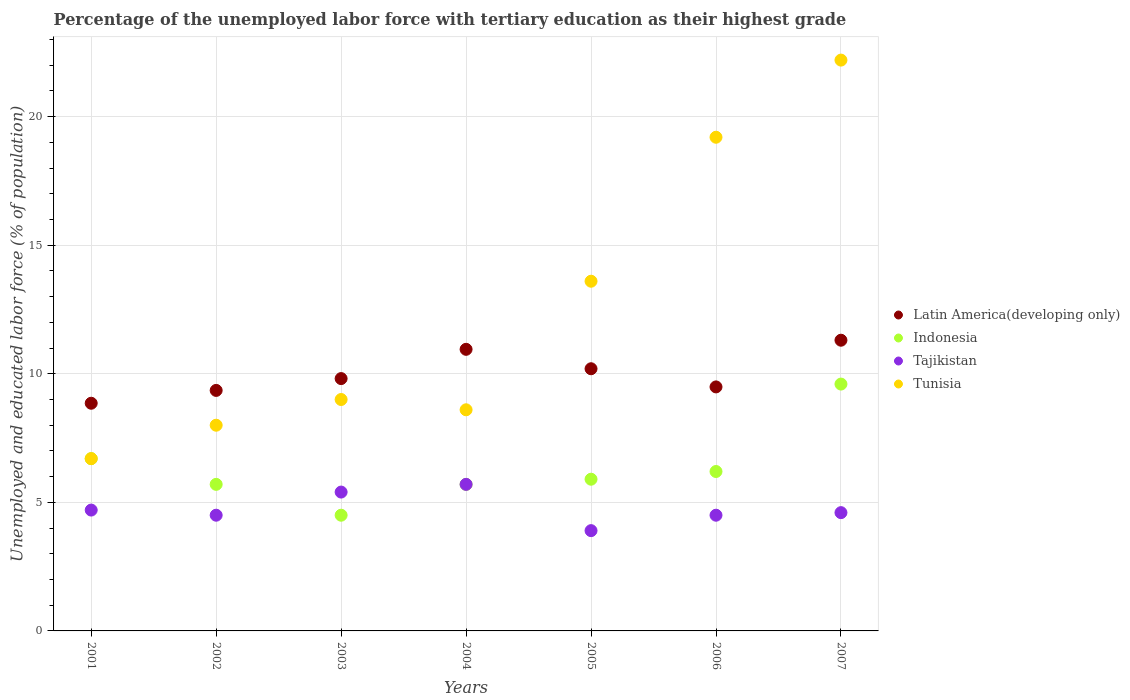Is the number of dotlines equal to the number of legend labels?
Ensure brevity in your answer.  Yes. What is the percentage of the unemployed labor force with tertiary education in Tajikistan in 2002?
Your response must be concise. 4.5. Across all years, what is the maximum percentage of the unemployed labor force with tertiary education in Latin America(developing only)?
Your response must be concise. 11.31. Across all years, what is the minimum percentage of the unemployed labor force with tertiary education in Latin America(developing only)?
Offer a terse response. 8.85. What is the total percentage of the unemployed labor force with tertiary education in Tunisia in the graph?
Your response must be concise. 87.3. What is the difference between the percentage of the unemployed labor force with tertiary education in Latin America(developing only) in 2005 and that in 2006?
Offer a terse response. 0.71. What is the difference between the percentage of the unemployed labor force with tertiary education in Latin America(developing only) in 2006 and the percentage of the unemployed labor force with tertiary education in Tunisia in 2005?
Give a very brief answer. -4.11. What is the average percentage of the unemployed labor force with tertiary education in Indonesia per year?
Keep it short and to the point. 6.33. In the year 2004, what is the difference between the percentage of the unemployed labor force with tertiary education in Tunisia and percentage of the unemployed labor force with tertiary education in Latin America(developing only)?
Your response must be concise. -2.35. In how many years, is the percentage of the unemployed labor force with tertiary education in Tunisia greater than 6 %?
Make the answer very short. 7. What is the ratio of the percentage of the unemployed labor force with tertiary education in Latin America(developing only) in 2004 to that in 2006?
Offer a terse response. 1.15. Is the percentage of the unemployed labor force with tertiary education in Tajikistan in 2003 less than that in 2007?
Provide a short and direct response. No. Is the difference between the percentage of the unemployed labor force with tertiary education in Tunisia in 2002 and 2004 greater than the difference between the percentage of the unemployed labor force with tertiary education in Latin America(developing only) in 2002 and 2004?
Provide a short and direct response. Yes. What is the difference between the highest and the lowest percentage of the unemployed labor force with tertiary education in Indonesia?
Keep it short and to the point. 5.1. Is it the case that in every year, the sum of the percentage of the unemployed labor force with tertiary education in Tunisia and percentage of the unemployed labor force with tertiary education in Indonesia  is greater than the sum of percentage of the unemployed labor force with tertiary education in Latin America(developing only) and percentage of the unemployed labor force with tertiary education in Tajikistan?
Keep it short and to the point. No. Is the percentage of the unemployed labor force with tertiary education in Tajikistan strictly greater than the percentage of the unemployed labor force with tertiary education in Latin America(developing only) over the years?
Provide a short and direct response. No. How many dotlines are there?
Make the answer very short. 4. What is the difference between two consecutive major ticks on the Y-axis?
Offer a terse response. 5. Does the graph contain grids?
Your answer should be very brief. Yes. How many legend labels are there?
Your response must be concise. 4. What is the title of the graph?
Offer a terse response. Percentage of the unemployed labor force with tertiary education as their highest grade. What is the label or title of the X-axis?
Your answer should be very brief. Years. What is the label or title of the Y-axis?
Keep it short and to the point. Unemployed and educated labor force (% of population). What is the Unemployed and educated labor force (% of population) in Latin America(developing only) in 2001?
Make the answer very short. 8.85. What is the Unemployed and educated labor force (% of population) in Indonesia in 2001?
Provide a succinct answer. 6.7. What is the Unemployed and educated labor force (% of population) in Tajikistan in 2001?
Ensure brevity in your answer.  4.7. What is the Unemployed and educated labor force (% of population) of Tunisia in 2001?
Keep it short and to the point. 6.7. What is the Unemployed and educated labor force (% of population) in Latin America(developing only) in 2002?
Provide a succinct answer. 9.35. What is the Unemployed and educated labor force (% of population) in Indonesia in 2002?
Keep it short and to the point. 5.7. What is the Unemployed and educated labor force (% of population) of Tunisia in 2002?
Ensure brevity in your answer.  8. What is the Unemployed and educated labor force (% of population) in Latin America(developing only) in 2003?
Offer a very short reply. 9.81. What is the Unemployed and educated labor force (% of population) of Indonesia in 2003?
Offer a terse response. 4.5. What is the Unemployed and educated labor force (% of population) of Tajikistan in 2003?
Provide a succinct answer. 5.4. What is the Unemployed and educated labor force (% of population) in Latin America(developing only) in 2004?
Offer a very short reply. 10.95. What is the Unemployed and educated labor force (% of population) in Indonesia in 2004?
Provide a succinct answer. 5.7. What is the Unemployed and educated labor force (% of population) in Tajikistan in 2004?
Provide a short and direct response. 5.7. What is the Unemployed and educated labor force (% of population) of Tunisia in 2004?
Your answer should be compact. 8.6. What is the Unemployed and educated labor force (% of population) of Latin America(developing only) in 2005?
Provide a succinct answer. 10.2. What is the Unemployed and educated labor force (% of population) in Indonesia in 2005?
Make the answer very short. 5.9. What is the Unemployed and educated labor force (% of population) of Tajikistan in 2005?
Offer a very short reply. 3.9. What is the Unemployed and educated labor force (% of population) of Tunisia in 2005?
Offer a very short reply. 13.6. What is the Unemployed and educated labor force (% of population) of Latin America(developing only) in 2006?
Your answer should be very brief. 9.49. What is the Unemployed and educated labor force (% of population) of Indonesia in 2006?
Keep it short and to the point. 6.2. What is the Unemployed and educated labor force (% of population) in Tajikistan in 2006?
Your answer should be very brief. 4.5. What is the Unemployed and educated labor force (% of population) in Tunisia in 2006?
Offer a terse response. 19.2. What is the Unemployed and educated labor force (% of population) in Latin America(developing only) in 2007?
Provide a short and direct response. 11.31. What is the Unemployed and educated labor force (% of population) of Indonesia in 2007?
Offer a terse response. 9.6. What is the Unemployed and educated labor force (% of population) in Tajikistan in 2007?
Offer a very short reply. 4.6. What is the Unemployed and educated labor force (% of population) in Tunisia in 2007?
Your response must be concise. 22.2. Across all years, what is the maximum Unemployed and educated labor force (% of population) in Latin America(developing only)?
Keep it short and to the point. 11.31. Across all years, what is the maximum Unemployed and educated labor force (% of population) in Indonesia?
Your response must be concise. 9.6. Across all years, what is the maximum Unemployed and educated labor force (% of population) in Tajikistan?
Give a very brief answer. 5.7. Across all years, what is the maximum Unemployed and educated labor force (% of population) of Tunisia?
Make the answer very short. 22.2. Across all years, what is the minimum Unemployed and educated labor force (% of population) in Latin America(developing only)?
Ensure brevity in your answer.  8.85. Across all years, what is the minimum Unemployed and educated labor force (% of population) in Indonesia?
Offer a very short reply. 4.5. Across all years, what is the minimum Unemployed and educated labor force (% of population) of Tajikistan?
Your answer should be very brief. 3.9. Across all years, what is the minimum Unemployed and educated labor force (% of population) in Tunisia?
Provide a short and direct response. 6.7. What is the total Unemployed and educated labor force (% of population) of Latin America(developing only) in the graph?
Provide a succinct answer. 69.97. What is the total Unemployed and educated labor force (% of population) in Indonesia in the graph?
Your response must be concise. 44.3. What is the total Unemployed and educated labor force (% of population) in Tajikistan in the graph?
Your answer should be very brief. 33.3. What is the total Unemployed and educated labor force (% of population) in Tunisia in the graph?
Provide a succinct answer. 87.3. What is the difference between the Unemployed and educated labor force (% of population) of Latin America(developing only) in 2001 and that in 2002?
Give a very brief answer. -0.5. What is the difference between the Unemployed and educated labor force (% of population) of Tajikistan in 2001 and that in 2002?
Offer a terse response. 0.2. What is the difference between the Unemployed and educated labor force (% of population) of Tunisia in 2001 and that in 2002?
Offer a terse response. -1.3. What is the difference between the Unemployed and educated labor force (% of population) in Latin America(developing only) in 2001 and that in 2003?
Give a very brief answer. -0.96. What is the difference between the Unemployed and educated labor force (% of population) in Indonesia in 2001 and that in 2003?
Provide a short and direct response. 2.2. What is the difference between the Unemployed and educated labor force (% of population) in Tunisia in 2001 and that in 2003?
Keep it short and to the point. -2.3. What is the difference between the Unemployed and educated labor force (% of population) in Latin America(developing only) in 2001 and that in 2004?
Make the answer very short. -2.1. What is the difference between the Unemployed and educated labor force (% of population) of Indonesia in 2001 and that in 2004?
Offer a very short reply. 1. What is the difference between the Unemployed and educated labor force (% of population) of Latin America(developing only) in 2001 and that in 2005?
Provide a succinct answer. -1.34. What is the difference between the Unemployed and educated labor force (% of population) of Latin America(developing only) in 2001 and that in 2006?
Ensure brevity in your answer.  -0.64. What is the difference between the Unemployed and educated labor force (% of population) of Tunisia in 2001 and that in 2006?
Make the answer very short. -12.5. What is the difference between the Unemployed and educated labor force (% of population) of Latin America(developing only) in 2001 and that in 2007?
Offer a terse response. -2.45. What is the difference between the Unemployed and educated labor force (% of population) of Tunisia in 2001 and that in 2007?
Your answer should be compact. -15.5. What is the difference between the Unemployed and educated labor force (% of population) of Latin America(developing only) in 2002 and that in 2003?
Give a very brief answer. -0.46. What is the difference between the Unemployed and educated labor force (% of population) of Tajikistan in 2002 and that in 2003?
Your answer should be very brief. -0.9. What is the difference between the Unemployed and educated labor force (% of population) of Tunisia in 2002 and that in 2003?
Provide a short and direct response. -1. What is the difference between the Unemployed and educated labor force (% of population) of Latin America(developing only) in 2002 and that in 2004?
Offer a very short reply. -1.6. What is the difference between the Unemployed and educated labor force (% of population) of Indonesia in 2002 and that in 2004?
Ensure brevity in your answer.  0. What is the difference between the Unemployed and educated labor force (% of population) in Tunisia in 2002 and that in 2004?
Your response must be concise. -0.6. What is the difference between the Unemployed and educated labor force (% of population) in Latin America(developing only) in 2002 and that in 2005?
Your answer should be very brief. -0.84. What is the difference between the Unemployed and educated labor force (% of population) in Tunisia in 2002 and that in 2005?
Your response must be concise. -5.6. What is the difference between the Unemployed and educated labor force (% of population) of Latin America(developing only) in 2002 and that in 2006?
Offer a very short reply. -0.14. What is the difference between the Unemployed and educated labor force (% of population) of Latin America(developing only) in 2002 and that in 2007?
Your answer should be very brief. -1.95. What is the difference between the Unemployed and educated labor force (% of population) of Indonesia in 2002 and that in 2007?
Your answer should be very brief. -3.9. What is the difference between the Unemployed and educated labor force (% of population) in Tajikistan in 2002 and that in 2007?
Your response must be concise. -0.1. What is the difference between the Unemployed and educated labor force (% of population) of Tunisia in 2002 and that in 2007?
Give a very brief answer. -14.2. What is the difference between the Unemployed and educated labor force (% of population) in Latin America(developing only) in 2003 and that in 2004?
Your response must be concise. -1.14. What is the difference between the Unemployed and educated labor force (% of population) of Indonesia in 2003 and that in 2004?
Ensure brevity in your answer.  -1.2. What is the difference between the Unemployed and educated labor force (% of population) of Latin America(developing only) in 2003 and that in 2005?
Offer a terse response. -0.38. What is the difference between the Unemployed and educated labor force (% of population) in Tajikistan in 2003 and that in 2005?
Make the answer very short. 1.5. What is the difference between the Unemployed and educated labor force (% of population) of Latin America(developing only) in 2003 and that in 2006?
Offer a very short reply. 0.32. What is the difference between the Unemployed and educated labor force (% of population) of Indonesia in 2003 and that in 2006?
Your answer should be compact. -1.7. What is the difference between the Unemployed and educated labor force (% of population) in Tunisia in 2003 and that in 2006?
Make the answer very short. -10.2. What is the difference between the Unemployed and educated labor force (% of population) in Latin America(developing only) in 2003 and that in 2007?
Provide a short and direct response. -1.49. What is the difference between the Unemployed and educated labor force (% of population) of Indonesia in 2003 and that in 2007?
Keep it short and to the point. -5.1. What is the difference between the Unemployed and educated labor force (% of population) in Latin America(developing only) in 2004 and that in 2005?
Provide a succinct answer. 0.76. What is the difference between the Unemployed and educated labor force (% of population) of Tunisia in 2004 and that in 2005?
Ensure brevity in your answer.  -5. What is the difference between the Unemployed and educated labor force (% of population) in Latin America(developing only) in 2004 and that in 2006?
Provide a short and direct response. 1.46. What is the difference between the Unemployed and educated labor force (% of population) of Indonesia in 2004 and that in 2006?
Your answer should be very brief. -0.5. What is the difference between the Unemployed and educated labor force (% of population) of Tajikistan in 2004 and that in 2006?
Offer a very short reply. 1.2. What is the difference between the Unemployed and educated labor force (% of population) of Tunisia in 2004 and that in 2006?
Give a very brief answer. -10.6. What is the difference between the Unemployed and educated labor force (% of population) in Latin America(developing only) in 2004 and that in 2007?
Make the answer very short. -0.35. What is the difference between the Unemployed and educated labor force (% of population) of Tajikistan in 2004 and that in 2007?
Make the answer very short. 1.1. What is the difference between the Unemployed and educated labor force (% of population) of Tunisia in 2004 and that in 2007?
Your answer should be very brief. -13.6. What is the difference between the Unemployed and educated labor force (% of population) of Latin America(developing only) in 2005 and that in 2006?
Provide a short and direct response. 0.71. What is the difference between the Unemployed and educated labor force (% of population) in Indonesia in 2005 and that in 2006?
Ensure brevity in your answer.  -0.3. What is the difference between the Unemployed and educated labor force (% of population) of Latin America(developing only) in 2005 and that in 2007?
Offer a very short reply. -1.11. What is the difference between the Unemployed and educated labor force (% of population) in Tajikistan in 2005 and that in 2007?
Provide a succinct answer. -0.7. What is the difference between the Unemployed and educated labor force (% of population) in Latin America(developing only) in 2006 and that in 2007?
Provide a short and direct response. -1.82. What is the difference between the Unemployed and educated labor force (% of population) of Indonesia in 2006 and that in 2007?
Your answer should be very brief. -3.4. What is the difference between the Unemployed and educated labor force (% of population) in Latin America(developing only) in 2001 and the Unemployed and educated labor force (% of population) in Indonesia in 2002?
Your response must be concise. 3.15. What is the difference between the Unemployed and educated labor force (% of population) of Latin America(developing only) in 2001 and the Unemployed and educated labor force (% of population) of Tajikistan in 2002?
Your answer should be compact. 4.35. What is the difference between the Unemployed and educated labor force (% of population) of Latin America(developing only) in 2001 and the Unemployed and educated labor force (% of population) of Tunisia in 2002?
Offer a very short reply. 0.85. What is the difference between the Unemployed and educated labor force (% of population) of Latin America(developing only) in 2001 and the Unemployed and educated labor force (% of population) of Indonesia in 2003?
Ensure brevity in your answer.  4.35. What is the difference between the Unemployed and educated labor force (% of population) in Latin America(developing only) in 2001 and the Unemployed and educated labor force (% of population) in Tajikistan in 2003?
Offer a very short reply. 3.45. What is the difference between the Unemployed and educated labor force (% of population) of Latin America(developing only) in 2001 and the Unemployed and educated labor force (% of population) of Tunisia in 2003?
Offer a terse response. -0.15. What is the difference between the Unemployed and educated labor force (% of population) in Tajikistan in 2001 and the Unemployed and educated labor force (% of population) in Tunisia in 2003?
Provide a short and direct response. -4.3. What is the difference between the Unemployed and educated labor force (% of population) of Latin America(developing only) in 2001 and the Unemployed and educated labor force (% of population) of Indonesia in 2004?
Your response must be concise. 3.15. What is the difference between the Unemployed and educated labor force (% of population) in Latin America(developing only) in 2001 and the Unemployed and educated labor force (% of population) in Tajikistan in 2004?
Provide a short and direct response. 3.15. What is the difference between the Unemployed and educated labor force (% of population) in Latin America(developing only) in 2001 and the Unemployed and educated labor force (% of population) in Tunisia in 2004?
Provide a short and direct response. 0.25. What is the difference between the Unemployed and educated labor force (% of population) in Indonesia in 2001 and the Unemployed and educated labor force (% of population) in Tajikistan in 2004?
Make the answer very short. 1. What is the difference between the Unemployed and educated labor force (% of population) of Tajikistan in 2001 and the Unemployed and educated labor force (% of population) of Tunisia in 2004?
Your answer should be compact. -3.9. What is the difference between the Unemployed and educated labor force (% of population) of Latin America(developing only) in 2001 and the Unemployed and educated labor force (% of population) of Indonesia in 2005?
Your answer should be compact. 2.95. What is the difference between the Unemployed and educated labor force (% of population) in Latin America(developing only) in 2001 and the Unemployed and educated labor force (% of population) in Tajikistan in 2005?
Your answer should be compact. 4.95. What is the difference between the Unemployed and educated labor force (% of population) in Latin America(developing only) in 2001 and the Unemployed and educated labor force (% of population) in Tunisia in 2005?
Keep it short and to the point. -4.75. What is the difference between the Unemployed and educated labor force (% of population) in Indonesia in 2001 and the Unemployed and educated labor force (% of population) in Tajikistan in 2005?
Give a very brief answer. 2.8. What is the difference between the Unemployed and educated labor force (% of population) in Indonesia in 2001 and the Unemployed and educated labor force (% of population) in Tunisia in 2005?
Your response must be concise. -6.9. What is the difference between the Unemployed and educated labor force (% of population) in Tajikistan in 2001 and the Unemployed and educated labor force (% of population) in Tunisia in 2005?
Your answer should be very brief. -8.9. What is the difference between the Unemployed and educated labor force (% of population) of Latin America(developing only) in 2001 and the Unemployed and educated labor force (% of population) of Indonesia in 2006?
Ensure brevity in your answer.  2.65. What is the difference between the Unemployed and educated labor force (% of population) in Latin America(developing only) in 2001 and the Unemployed and educated labor force (% of population) in Tajikistan in 2006?
Your response must be concise. 4.35. What is the difference between the Unemployed and educated labor force (% of population) in Latin America(developing only) in 2001 and the Unemployed and educated labor force (% of population) in Tunisia in 2006?
Offer a terse response. -10.35. What is the difference between the Unemployed and educated labor force (% of population) in Indonesia in 2001 and the Unemployed and educated labor force (% of population) in Tajikistan in 2006?
Offer a terse response. 2.2. What is the difference between the Unemployed and educated labor force (% of population) of Tajikistan in 2001 and the Unemployed and educated labor force (% of population) of Tunisia in 2006?
Offer a very short reply. -14.5. What is the difference between the Unemployed and educated labor force (% of population) of Latin America(developing only) in 2001 and the Unemployed and educated labor force (% of population) of Indonesia in 2007?
Give a very brief answer. -0.75. What is the difference between the Unemployed and educated labor force (% of population) in Latin America(developing only) in 2001 and the Unemployed and educated labor force (% of population) in Tajikistan in 2007?
Offer a very short reply. 4.25. What is the difference between the Unemployed and educated labor force (% of population) in Latin America(developing only) in 2001 and the Unemployed and educated labor force (% of population) in Tunisia in 2007?
Your answer should be very brief. -13.35. What is the difference between the Unemployed and educated labor force (% of population) in Indonesia in 2001 and the Unemployed and educated labor force (% of population) in Tunisia in 2007?
Your answer should be very brief. -15.5. What is the difference between the Unemployed and educated labor force (% of population) of Tajikistan in 2001 and the Unemployed and educated labor force (% of population) of Tunisia in 2007?
Give a very brief answer. -17.5. What is the difference between the Unemployed and educated labor force (% of population) in Latin America(developing only) in 2002 and the Unemployed and educated labor force (% of population) in Indonesia in 2003?
Make the answer very short. 4.85. What is the difference between the Unemployed and educated labor force (% of population) in Latin America(developing only) in 2002 and the Unemployed and educated labor force (% of population) in Tajikistan in 2003?
Offer a very short reply. 3.95. What is the difference between the Unemployed and educated labor force (% of population) in Latin America(developing only) in 2002 and the Unemployed and educated labor force (% of population) in Tunisia in 2003?
Your answer should be very brief. 0.35. What is the difference between the Unemployed and educated labor force (% of population) of Indonesia in 2002 and the Unemployed and educated labor force (% of population) of Tajikistan in 2003?
Your response must be concise. 0.3. What is the difference between the Unemployed and educated labor force (% of population) of Latin America(developing only) in 2002 and the Unemployed and educated labor force (% of population) of Indonesia in 2004?
Provide a succinct answer. 3.65. What is the difference between the Unemployed and educated labor force (% of population) in Latin America(developing only) in 2002 and the Unemployed and educated labor force (% of population) in Tajikistan in 2004?
Ensure brevity in your answer.  3.65. What is the difference between the Unemployed and educated labor force (% of population) in Latin America(developing only) in 2002 and the Unemployed and educated labor force (% of population) in Tunisia in 2004?
Your answer should be very brief. 0.75. What is the difference between the Unemployed and educated labor force (% of population) of Indonesia in 2002 and the Unemployed and educated labor force (% of population) of Tunisia in 2004?
Your answer should be compact. -2.9. What is the difference between the Unemployed and educated labor force (% of population) in Tajikistan in 2002 and the Unemployed and educated labor force (% of population) in Tunisia in 2004?
Provide a short and direct response. -4.1. What is the difference between the Unemployed and educated labor force (% of population) of Latin America(developing only) in 2002 and the Unemployed and educated labor force (% of population) of Indonesia in 2005?
Your response must be concise. 3.45. What is the difference between the Unemployed and educated labor force (% of population) in Latin America(developing only) in 2002 and the Unemployed and educated labor force (% of population) in Tajikistan in 2005?
Ensure brevity in your answer.  5.45. What is the difference between the Unemployed and educated labor force (% of population) in Latin America(developing only) in 2002 and the Unemployed and educated labor force (% of population) in Tunisia in 2005?
Provide a succinct answer. -4.25. What is the difference between the Unemployed and educated labor force (% of population) of Tajikistan in 2002 and the Unemployed and educated labor force (% of population) of Tunisia in 2005?
Offer a terse response. -9.1. What is the difference between the Unemployed and educated labor force (% of population) in Latin America(developing only) in 2002 and the Unemployed and educated labor force (% of population) in Indonesia in 2006?
Provide a short and direct response. 3.15. What is the difference between the Unemployed and educated labor force (% of population) in Latin America(developing only) in 2002 and the Unemployed and educated labor force (% of population) in Tajikistan in 2006?
Offer a very short reply. 4.85. What is the difference between the Unemployed and educated labor force (% of population) in Latin America(developing only) in 2002 and the Unemployed and educated labor force (% of population) in Tunisia in 2006?
Offer a very short reply. -9.85. What is the difference between the Unemployed and educated labor force (% of population) of Indonesia in 2002 and the Unemployed and educated labor force (% of population) of Tajikistan in 2006?
Offer a terse response. 1.2. What is the difference between the Unemployed and educated labor force (% of population) of Tajikistan in 2002 and the Unemployed and educated labor force (% of population) of Tunisia in 2006?
Offer a terse response. -14.7. What is the difference between the Unemployed and educated labor force (% of population) in Latin America(developing only) in 2002 and the Unemployed and educated labor force (% of population) in Indonesia in 2007?
Keep it short and to the point. -0.25. What is the difference between the Unemployed and educated labor force (% of population) of Latin America(developing only) in 2002 and the Unemployed and educated labor force (% of population) of Tajikistan in 2007?
Your answer should be very brief. 4.75. What is the difference between the Unemployed and educated labor force (% of population) of Latin America(developing only) in 2002 and the Unemployed and educated labor force (% of population) of Tunisia in 2007?
Make the answer very short. -12.85. What is the difference between the Unemployed and educated labor force (% of population) in Indonesia in 2002 and the Unemployed and educated labor force (% of population) in Tajikistan in 2007?
Your answer should be very brief. 1.1. What is the difference between the Unemployed and educated labor force (% of population) in Indonesia in 2002 and the Unemployed and educated labor force (% of population) in Tunisia in 2007?
Keep it short and to the point. -16.5. What is the difference between the Unemployed and educated labor force (% of population) of Tajikistan in 2002 and the Unemployed and educated labor force (% of population) of Tunisia in 2007?
Your answer should be compact. -17.7. What is the difference between the Unemployed and educated labor force (% of population) in Latin America(developing only) in 2003 and the Unemployed and educated labor force (% of population) in Indonesia in 2004?
Ensure brevity in your answer.  4.11. What is the difference between the Unemployed and educated labor force (% of population) in Latin America(developing only) in 2003 and the Unemployed and educated labor force (% of population) in Tajikistan in 2004?
Keep it short and to the point. 4.11. What is the difference between the Unemployed and educated labor force (% of population) in Latin America(developing only) in 2003 and the Unemployed and educated labor force (% of population) in Tunisia in 2004?
Your answer should be compact. 1.21. What is the difference between the Unemployed and educated labor force (% of population) in Tajikistan in 2003 and the Unemployed and educated labor force (% of population) in Tunisia in 2004?
Your response must be concise. -3.2. What is the difference between the Unemployed and educated labor force (% of population) of Latin America(developing only) in 2003 and the Unemployed and educated labor force (% of population) of Indonesia in 2005?
Provide a short and direct response. 3.91. What is the difference between the Unemployed and educated labor force (% of population) in Latin America(developing only) in 2003 and the Unemployed and educated labor force (% of population) in Tajikistan in 2005?
Offer a terse response. 5.91. What is the difference between the Unemployed and educated labor force (% of population) of Latin America(developing only) in 2003 and the Unemployed and educated labor force (% of population) of Tunisia in 2005?
Offer a very short reply. -3.79. What is the difference between the Unemployed and educated labor force (% of population) in Indonesia in 2003 and the Unemployed and educated labor force (% of population) in Tajikistan in 2005?
Provide a short and direct response. 0.6. What is the difference between the Unemployed and educated labor force (% of population) in Latin America(developing only) in 2003 and the Unemployed and educated labor force (% of population) in Indonesia in 2006?
Your response must be concise. 3.61. What is the difference between the Unemployed and educated labor force (% of population) of Latin America(developing only) in 2003 and the Unemployed and educated labor force (% of population) of Tajikistan in 2006?
Your answer should be very brief. 5.31. What is the difference between the Unemployed and educated labor force (% of population) in Latin America(developing only) in 2003 and the Unemployed and educated labor force (% of population) in Tunisia in 2006?
Ensure brevity in your answer.  -9.39. What is the difference between the Unemployed and educated labor force (% of population) of Indonesia in 2003 and the Unemployed and educated labor force (% of population) of Tunisia in 2006?
Make the answer very short. -14.7. What is the difference between the Unemployed and educated labor force (% of population) of Tajikistan in 2003 and the Unemployed and educated labor force (% of population) of Tunisia in 2006?
Ensure brevity in your answer.  -13.8. What is the difference between the Unemployed and educated labor force (% of population) in Latin America(developing only) in 2003 and the Unemployed and educated labor force (% of population) in Indonesia in 2007?
Your response must be concise. 0.21. What is the difference between the Unemployed and educated labor force (% of population) in Latin America(developing only) in 2003 and the Unemployed and educated labor force (% of population) in Tajikistan in 2007?
Make the answer very short. 5.21. What is the difference between the Unemployed and educated labor force (% of population) of Latin America(developing only) in 2003 and the Unemployed and educated labor force (% of population) of Tunisia in 2007?
Give a very brief answer. -12.39. What is the difference between the Unemployed and educated labor force (% of population) of Indonesia in 2003 and the Unemployed and educated labor force (% of population) of Tunisia in 2007?
Your answer should be compact. -17.7. What is the difference between the Unemployed and educated labor force (% of population) of Tajikistan in 2003 and the Unemployed and educated labor force (% of population) of Tunisia in 2007?
Keep it short and to the point. -16.8. What is the difference between the Unemployed and educated labor force (% of population) of Latin America(developing only) in 2004 and the Unemployed and educated labor force (% of population) of Indonesia in 2005?
Ensure brevity in your answer.  5.05. What is the difference between the Unemployed and educated labor force (% of population) in Latin America(developing only) in 2004 and the Unemployed and educated labor force (% of population) in Tajikistan in 2005?
Offer a very short reply. 7.05. What is the difference between the Unemployed and educated labor force (% of population) in Latin America(developing only) in 2004 and the Unemployed and educated labor force (% of population) in Tunisia in 2005?
Your response must be concise. -2.65. What is the difference between the Unemployed and educated labor force (% of population) in Indonesia in 2004 and the Unemployed and educated labor force (% of population) in Tajikistan in 2005?
Provide a short and direct response. 1.8. What is the difference between the Unemployed and educated labor force (% of population) of Latin America(developing only) in 2004 and the Unemployed and educated labor force (% of population) of Indonesia in 2006?
Ensure brevity in your answer.  4.75. What is the difference between the Unemployed and educated labor force (% of population) of Latin America(developing only) in 2004 and the Unemployed and educated labor force (% of population) of Tajikistan in 2006?
Offer a terse response. 6.45. What is the difference between the Unemployed and educated labor force (% of population) of Latin America(developing only) in 2004 and the Unemployed and educated labor force (% of population) of Tunisia in 2006?
Keep it short and to the point. -8.25. What is the difference between the Unemployed and educated labor force (% of population) of Indonesia in 2004 and the Unemployed and educated labor force (% of population) of Tajikistan in 2006?
Give a very brief answer. 1.2. What is the difference between the Unemployed and educated labor force (% of population) in Indonesia in 2004 and the Unemployed and educated labor force (% of population) in Tunisia in 2006?
Keep it short and to the point. -13.5. What is the difference between the Unemployed and educated labor force (% of population) of Tajikistan in 2004 and the Unemployed and educated labor force (% of population) of Tunisia in 2006?
Keep it short and to the point. -13.5. What is the difference between the Unemployed and educated labor force (% of population) of Latin America(developing only) in 2004 and the Unemployed and educated labor force (% of population) of Indonesia in 2007?
Make the answer very short. 1.35. What is the difference between the Unemployed and educated labor force (% of population) of Latin America(developing only) in 2004 and the Unemployed and educated labor force (% of population) of Tajikistan in 2007?
Keep it short and to the point. 6.35. What is the difference between the Unemployed and educated labor force (% of population) in Latin America(developing only) in 2004 and the Unemployed and educated labor force (% of population) in Tunisia in 2007?
Make the answer very short. -11.25. What is the difference between the Unemployed and educated labor force (% of population) of Indonesia in 2004 and the Unemployed and educated labor force (% of population) of Tajikistan in 2007?
Make the answer very short. 1.1. What is the difference between the Unemployed and educated labor force (% of population) in Indonesia in 2004 and the Unemployed and educated labor force (% of population) in Tunisia in 2007?
Your answer should be very brief. -16.5. What is the difference between the Unemployed and educated labor force (% of population) in Tajikistan in 2004 and the Unemployed and educated labor force (% of population) in Tunisia in 2007?
Offer a terse response. -16.5. What is the difference between the Unemployed and educated labor force (% of population) of Latin America(developing only) in 2005 and the Unemployed and educated labor force (% of population) of Indonesia in 2006?
Keep it short and to the point. 4. What is the difference between the Unemployed and educated labor force (% of population) of Latin America(developing only) in 2005 and the Unemployed and educated labor force (% of population) of Tajikistan in 2006?
Your answer should be very brief. 5.7. What is the difference between the Unemployed and educated labor force (% of population) in Latin America(developing only) in 2005 and the Unemployed and educated labor force (% of population) in Tunisia in 2006?
Provide a short and direct response. -9. What is the difference between the Unemployed and educated labor force (% of population) in Indonesia in 2005 and the Unemployed and educated labor force (% of population) in Tajikistan in 2006?
Provide a succinct answer. 1.4. What is the difference between the Unemployed and educated labor force (% of population) of Tajikistan in 2005 and the Unemployed and educated labor force (% of population) of Tunisia in 2006?
Your answer should be compact. -15.3. What is the difference between the Unemployed and educated labor force (% of population) of Latin America(developing only) in 2005 and the Unemployed and educated labor force (% of population) of Indonesia in 2007?
Give a very brief answer. 0.6. What is the difference between the Unemployed and educated labor force (% of population) in Latin America(developing only) in 2005 and the Unemployed and educated labor force (% of population) in Tajikistan in 2007?
Ensure brevity in your answer.  5.6. What is the difference between the Unemployed and educated labor force (% of population) in Latin America(developing only) in 2005 and the Unemployed and educated labor force (% of population) in Tunisia in 2007?
Your answer should be compact. -12. What is the difference between the Unemployed and educated labor force (% of population) in Indonesia in 2005 and the Unemployed and educated labor force (% of population) in Tunisia in 2007?
Your answer should be compact. -16.3. What is the difference between the Unemployed and educated labor force (% of population) of Tajikistan in 2005 and the Unemployed and educated labor force (% of population) of Tunisia in 2007?
Your answer should be compact. -18.3. What is the difference between the Unemployed and educated labor force (% of population) in Latin America(developing only) in 2006 and the Unemployed and educated labor force (% of population) in Indonesia in 2007?
Keep it short and to the point. -0.11. What is the difference between the Unemployed and educated labor force (% of population) in Latin America(developing only) in 2006 and the Unemployed and educated labor force (% of population) in Tajikistan in 2007?
Provide a succinct answer. 4.89. What is the difference between the Unemployed and educated labor force (% of population) of Latin America(developing only) in 2006 and the Unemployed and educated labor force (% of population) of Tunisia in 2007?
Ensure brevity in your answer.  -12.71. What is the difference between the Unemployed and educated labor force (% of population) of Indonesia in 2006 and the Unemployed and educated labor force (% of population) of Tunisia in 2007?
Your answer should be very brief. -16. What is the difference between the Unemployed and educated labor force (% of population) in Tajikistan in 2006 and the Unemployed and educated labor force (% of population) in Tunisia in 2007?
Your response must be concise. -17.7. What is the average Unemployed and educated labor force (% of population) in Latin America(developing only) per year?
Offer a terse response. 10. What is the average Unemployed and educated labor force (% of population) in Indonesia per year?
Offer a terse response. 6.33. What is the average Unemployed and educated labor force (% of population) of Tajikistan per year?
Offer a terse response. 4.76. What is the average Unemployed and educated labor force (% of population) of Tunisia per year?
Provide a short and direct response. 12.47. In the year 2001, what is the difference between the Unemployed and educated labor force (% of population) in Latin America(developing only) and Unemployed and educated labor force (% of population) in Indonesia?
Your answer should be compact. 2.15. In the year 2001, what is the difference between the Unemployed and educated labor force (% of population) of Latin America(developing only) and Unemployed and educated labor force (% of population) of Tajikistan?
Provide a short and direct response. 4.15. In the year 2001, what is the difference between the Unemployed and educated labor force (% of population) of Latin America(developing only) and Unemployed and educated labor force (% of population) of Tunisia?
Make the answer very short. 2.15. In the year 2001, what is the difference between the Unemployed and educated labor force (% of population) of Indonesia and Unemployed and educated labor force (% of population) of Tajikistan?
Your response must be concise. 2. In the year 2002, what is the difference between the Unemployed and educated labor force (% of population) of Latin America(developing only) and Unemployed and educated labor force (% of population) of Indonesia?
Ensure brevity in your answer.  3.65. In the year 2002, what is the difference between the Unemployed and educated labor force (% of population) of Latin America(developing only) and Unemployed and educated labor force (% of population) of Tajikistan?
Ensure brevity in your answer.  4.85. In the year 2002, what is the difference between the Unemployed and educated labor force (% of population) in Latin America(developing only) and Unemployed and educated labor force (% of population) in Tunisia?
Your answer should be very brief. 1.35. In the year 2002, what is the difference between the Unemployed and educated labor force (% of population) in Indonesia and Unemployed and educated labor force (% of population) in Tajikistan?
Make the answer very short. 1.2. In the year 2003, what is the difference between the Unemployed and educated labor force (% of population) of Latin America(developing only) and Unemployed and educated labor force (% of population) of Indonesia?
Provide a succinct answer. 5.31. In the year 2003, what is the difference between the Unemployed and educated labor force (% of population) in Latin America(developing only) and Unemployed and educated labor force (% of population) in Tajikistan?
Keep it short and to the point. 4.41. In the year 2003, what is the difference between the Unemployed and educated labor force (% of population) in Latin America(developing only) and Unemployed and educated labor force (% of population) in Tunisia?
Your response must be concise. 0.81. In the year 2004, what is the difference between the Unemployed and educated labor force (% of population) in Latin America(developing only) and Unemployed and educated labor force (% of population) in Indonesia?
Your answer should be very brief. 5.25. In the year 2004, what is the difference between the Unemployed and educated labor force (% of population) of Latin America(developing only) and Unemployed and educated labor force (% of population) of Tajikistan?
Offer a very short reply. 5.25. In the year 2004, what is the difference between the Unemployed and educated labor force (% of population) of Latin America(developing only) and Unemployed and educated labor force (% of population) of Tunisia?
Provide a succinct answer. 2.35. In the year 2004, what is the difference between the Unemployed and educated labor force (% of population) of Indonesia and Unemployed and educated labor force (% of population) of Tajikistan?
Your answer should be very brief. 0. In the year 2004, what is the difference between the Unemployed and educated labor force (% of population) in Indonesia and Unemployed and educated labor force (% of population) in Tunisia?
Provide a short and direct response. -2.9. In the year 2005, what is the difference between the Unemployed and educated labor force (% of population) in Latin America(developing only) and Unemployed and educated labor force (% of population) in Indonesia?
Make the answer very short. 4.3. In the year 2005, what is the difference between the Unemployed and educated labor force (% of population) of Latin America(developing only) and Unemployed and educated labor force (% of population) of Tajikistan?
Make the answer very short. 6.3. In the year 2005, what is the difference between the Unemployed and educated labor force (% of population) of Latin America(developing only) and Unemployed and educated labor force (% of population) of Tunisia?
Provide a succinct answer. -3.4. In the year 2005, what is the difference between the Unemployed and educated labor force (% of population) in Tajikistan and Unemployed and educated labor force (% of population) in Tunisia?
Your answer should be compact. -9.7. In the year 2006, what is the difference between the Unemployed and educated labor force (% of population) in Latin America(developing only) and Unemployed and educated labor force (% of population) in Indonesia?
Give a very brief answer. 3.29. In the year 2006, what is the difference between the Unemployed and educated labor force (% of population) in Latin America(developing only) and Unemployed and educated labor force (% of population) in Tajikistan?
Offer a terse response. 4.99. In the year 2006, what is the difference between the Unemployed and educated labor force (% of population) of Latin America(developing only) and Unemployed and educated labor force (% of population) of Tunisia?
Provide a succinct answer. -9.71. In the year 2006, what is the difference between the Unemployed and educated labor force (% of population) of Indonesia and Unemployed and educated labor force (% of population) of Tunisia?
Make the answer very short. -13. In the year 2006, what is the difference between the Unemployed and educated labor force (% of population) of Tajikistan and Unemployed and educated labor force (% of population) of Tunisia?
Give a very brief answer. -14.7. In the year 2007, what is the difference between the Unemployed and educated labor force (% of population) in Latin America(developing only) and Unemployed and educated labor force (% of population) in Indonesia?
Provide a succinct answer. 1.71. In the year 2007, what is the difference between the Unemployed and educated labor force (% of population) in Latin America(developing only) and Unemployed and educated labor force (% of population) in Tajikistan?
Your answer should be very brief. 6.71. In the year 2007, what is the difference between the Unemployed and educated labor force (% of population) in Latin America(developing only) and Unemployed and educated labor force (% of population) in Tunisia?
Offer a terse response. -10.89. In the year 2007, what is the difference between the Unemployed and educated labor force (% of population) of Tajikistan and Unemployed and educated labor force (% of population) of Tunisia?
Ensure brevity in your answer.  -17.6. What is the ratio of the Unemployed and educated labor force (% of population) in Latin America(developing only) in 2001 to that in 2002?
Your answer should be very brief. 0.95. What is the ratio of the Unemployed and educated labor force (% of population) of Indonesia in 2001 to that in 2002?
Your response must be concise. 1.18. What is the ratio of the Unemployed and educated labor force (% of population) of Tajikistan in 2001 to that in 2002?
Offer a terse response. 1.04. What is the ratio of the Unemployed and educated labor force (% of population) in Tunisia in 2001 to that in 2002?
Offer a very short reply. 0.84. What is the ratio of the Unemployed and educated labor force (% of population) in Latin America(developing only) in 2001 to that in 2003?
Your response must be concise. 0.9. What is the ratio of the Unemployed and educated labor force (% of population) of Indonesia in 2001 to that in 2003?
Offer a very short reply. 1.49. What is the ratio of the Unemployed and educated labor force (% of population) of Tajikistan in 2001 to that in 2003?
Make the answer very short. 0.87. What is the ratio of the Unemployed and educated labor force (% of population) in Tunisia in 2001 to that in 2003?
Your answer should be very brief. 0.74. What is the ratio of the Unemployed and educated labor force (% of population) in Latin America(developing only) in 2001 to that in 2004?
Offer a terse response. 0.81. What is the ratio of the Unemployed and educated labor force (% of population) of Indonesia in 2001 to that in 2004?
Offer a very short reply. 1.18. What is the ratio of the Unemployed and educated labor force (% of population) in Tajikistan in 2001 to that in 2004?
Ensure brevity in your answer.  0.82. What is the ratio of the Unemployed and educated labor force (% of population) in Tunisia in 2001 to that in 2004?
Provide a short and direct response. 0.78. What is the ratio of the Unemployed and educated labor force (% of population) in Latin America(developing only) in 2001 to that in 2005?
Ensure brevity in your answer.  0.87. What is the ratio of the Unemployed and educated labor force (% of population) in Indonesia in 2001 to that in 2005?
Your answer should be compact. 1.14. What is the ratio of the Unemployed and educated labor force (% of population) of Tajikistan in 2001 to that in 2005?
Your response must be concise. 1.21. What is the ratio of the Unemployed and educated labor force (% of population) in Tunisia in 2001 to that in 2005?
Offer a very short reply. 0.49. What is the ratio of the Unemployed and educated labor force (% of population) in Latin America(developing only) in 2001 to that in 2006?
Keep it short and to the point. 0.93. What is the ratio of the Unemployed and educated labor force (% of population) in Indonesia in 2001 to that in 2006?
Ensure brevity in your answer.  1.08. What is the ratio of the Unemployed and educated labor force (% of population) of Tajikistan in 2001 to that in 2006?
Provide a short and direct response. 1.04. What is the ratio of the Unemployed and educated labor force (% of population) in Tunisia in 2001 to that in 2006?
Offer a terse response. 0.35. What is the ratio of the Unemployed and educated labor force (% of population) of Latin America(developing only) in 2001 to that in 2007?
Keep it short and to the point. 0.78. What is the ratio of the Unemployed and educated labor force (% of population) in Indonesia in 2001 to that in 2007?
Provide a short and direct response. 0.7. What is the ratio of the Unemployed and educated labor force (% of population) in Tajikistan in 2001 to that in 2007?
Provide a short and direct response. 1.02. What is the ratio of the Unemployed and educated labor force (% of population) in Tunisia in 2001 to that in 2007?
Make the answer very short. 0.3. What is the ratio of the Unemployed and educated labor force (% of population) in Latin America(developing only) in 2002 to that in 2003?
Provide a succinct answer. 0.95. What is the ratio of the Unemployed and educated labor force (% of population) of Indonesia in 2002 to that in 2003?
Offer a terse response. 1.27. What is the ratio of the Unemployed and educated labor force (% of population) of Tunisia in 2002 to that in 2003?
Offer a very short reply. 0.89. What is the ratio of the Unemployed and educated labor force (% of population) in Latin America(developing only) in 2002 to that in 2004?
Your response must be concise. 0.85. What is the ratio of the Unemployed and educated labor force (% of population) in Indonesia in 2002 to that in 2004?
Offer a terse response. 1. What is the ratio of the Unemployed and educated labor force (% of population) in Tajikistan in 2002 to that in 2004?
Your answer should be very brief. 0.79. What is the ratio of the Unemployed and educated labor force (% of population) of Tunisia in 2002 to that in 2004?
Give a very brief answer. 0.93. What is the ratio of the Unemployed and educated labor force (% of population) in Latin America(developing only) in 2002 to that in 2005?
Make the answer very short. 0.92. What is the ratio of the Unemployed and educated labor force (% of population) of Indonesia in 2002 to that in 2005?
Provide a succinct answer. 0.97. What is the ratio of the Unemployed and educated labor force (% of population) in Tajikistan in 2002 to that in 2005?
Offer a terse response. 1.15. What is the ratio of the Unemployed and educated labor force (% of population) of Tunisia in 2002 to that in 2005?
Keep it short and to the point. 0.59. What is the ratio of the Unemployed and educated labor force (% of population) of Latin America(developing only) in 2002 to that in 2006?
Provide a short and direct response. 0.99. What is the ratio of the Unemployed and educated labor force (% of population) of Indonesia in 2002 to that in 2006?
Offer a terse response. 0.92. What is the ratio of the Unemployed and educated labor force (% of population) in Tajikistan in 2002 to that in 2006?
Your answer should be very brief. 1. What is the ratio of the Unemployed and educated labor force (% of population) of Tunisia in 2002 to that in 2006?
Offer a terse response. 0.42. What is the ratio of the Unemployed and educated labor force (% of population) in Latin America(developing only) in 2002 to that in 2007?
Give a very brief answer. 0.83. What is the ratio of the Unemployed and educated labor force (% of population) in Indonesia in 2002 to that in 2007?
Your answer should be compact. 0.59. What is the ratio of the Unemployed and educated labor force (% of population) of Tajikistan in 2002 to that in 2007?
Ensure brevity in your answer.  0.98. What is the ratio of the Unemployed and educated labor force (% of population) of Tunisia in 2002 to that in 2007?
Make the answer very short. 0.36. What is the ratio of the Unemployed and educated labor force (% of population) in Latin America(developing only) in 2003 to that in 2004?
Offer a very short reply. 0.9. What is the ratio of the Unemployed and educated labor force (% of population) of Indonesia in 2003 to that in 2004?
Provide a short and direct response. 0.79. What is the ratio of the Unemployed and educated labor force (% of population) in Tunisia in 2003 to that in 2004?
Your answer should be very brief. 1.05. What is the ratio of the Unemployed and educated labor force (% of population) of Latin America(developing only) in 2003 to that in 2005?
Keep it short and to the point. 0.96. What is the ratio of the Unemployed and educated labor force (% of population) of Indonesia in 2003 to that in 2005?
Your response must be concise. 0.76. What is the ratio of the Unemployed and educated labor force (% of population) of Tajikistan in 2003 to that in 2005?
Keep it short and to the point. 1.38. What is the ratio of the Unemployed and educated labor force (% of population) of Tunisia in 2003 to that in 2005?
Offer a terse response. 0.66. What is the ratio of the Unemployed and educated labor force (% of population) in Latin America(developing only) in 2003 to that in 2006?
Make the answer very short. 1.03. What is the ratio of the Unemployed and educated labor force (% of population) of Indonesia in 2003 to that in 2006?
Offer a very short reply. 0.73. What is the ratio of the Unemployed and educated labor force (% of population) in Tajikistan in 2003 to that in 2006?
Give a very brief answer. 1.2. What is the ratio of the Unemployed and educated labor force (% of population) in Tunisia in 2003 to that in 2006?
Keep it short and to the point. 0.47. What is the ratio of the Unemployed and educated labor force (% of population) of Latin America(developing only) in 2003 to that in 2007?
Provide a succinct answer. 0.87. What is the ratio of the Unemployed and educated labor force (% of population) of Indonesia in 2003 to that in 2007?
Your answer should be compact. 0.47. What is the ratio of the Unemployed and educated labor force (% of population) in Tajikistan in 2003 to that in 2007?
Make the answer very short. 1.17. What is the ratio of the Unemployed and educated labor force (% of population) in Tunisia in 2003 to that in 2007?
Your answer should be very brief. 0.41. What is the ratio of the Unemployed and educated labor force (% of population) of Latin America(developing only) in 2004 to that in 2005?
Your response must be concise. 1.07. What is the ratio of the Unemployed and educated labor force (% of population) of Indonesia in 2004 to that in 2005?
Offer a very short reply. 0.97. What is the ratio of the Unemployed and educated labor force (% of population) of Tajikistan in 2004 to that in 2005?
Your response must be concise. 1.46. What is the ratio of the Unemployed and educated labor force (% of population) of Tunisia in 2004 to that in 2005?
Offer a very short reply. 0.63. What is the ratio of the Unemployed and educated labor force (% of population) of Latin America(developing only) in 2004 to that in 2006?
Your answer should be compact. 1.15. What is the ratio of the Unemployed and educated labor force (% of population) in Indonesia in 2004 to that in 2006?
Your response must be concise. 0.92. What is the ratio of the Unemployed and educated labor force (% of population) of Tajikistan in 2004 to that in 2006?
Keep it short and to the point. 1.27. What is the ratio of the Unemployed and educated labor force (% of population) of Tunisia in 2004 to that in 2006?
Ensure brevity in your answer.  0.45. What is the ratio of the Unemployed and educated labor force (% of population) of Latin America(developing only) in 2004 to that in 2007?
Offer a very short reply. 0.97. What is the ratio of the Unemployed and educated labor force (% of population) in Indonesia in 2004 to that in 2007?
Give a very brief answer. 0.59. What is the ratio of the Unemployed and educated labor force (% of population) of Tajikistan in 2004 to that in 2007?
Your answer should be very brief. 1.24. What is the ratio of the Unemployed and educated labor force (% of population) of Tunisia in 2004 to that in 2007?
Your answer should be very brief. 0.39. What is the ratio of the Unemployed and educated labor force (% of population) of Latin America(developing only) in 2005 to that in 2006?
Give a very brief answer. 1.07. What is the ratio of the Unemployed and educated labor force (% of population) in Indonesia in 2005 to that in 2006?
Provide a short and direct response. 0.95. What is the ratio of the Unemployed and educated labor force (% of population) in Tajikistan in 2005 to that in 2006?
Ensure brevity in your answer.  0.87. What is the ratio of the Unemployed and educated labor force (% of population) in Tunisia in 2005 to that in 2006?
Make the answer very short. 0.71. What is the ratio of the Unemployed and educated labor force (% of population) in Latin America(developing only) in 2005 to that in 2007?
Keep it short and to the point. 0.9. What is the ratio of the Unemployed and educated labor force (% of population) of Indonesia in 2005 to that in 2007?
Ensure brevity in your answer.  0.61. What is the ratio of the Unemployed and educated labor force (% of population) in Tajikistan in 2005 to that in 2007?
Offer a terse response. 0.85. What is the ratio of the Unemployed and educated labor force (% of population) of Tunisia in 2005 to that in 2007?
Offer a very short reply. 0.61. What is the ratio of the Unemployed and educated labor force (% of population) in Latin America(developing only) in 2006 to that in 2007?
Keep it short and to the point. 0.84. What is the ratio of the Unemployed and educated labor force (% of population) in Indonesia in 2006 to that in 2007?
Your answer should be compact. 0.65. What is the ratio of the Unemployed and educated labor force (% of population) of Tajikistan in 2006 to that in 2007?
Your answer should be very brief. 0.98. What is the ratio of the Unemployed and educated labor force (% of population) of Tunisia in 2006 to that in 2007?
Ensure brevity in your answer.  0.86. What is the difference between the highest and the second highest Unemployed and educated labor force (% of population) of Latin America(developing only)?
Offer a very short reply. 0.35. What is the difference between the highest and the second highest Unemployed and educated labor force (% of population) of Tajikistan?
Your answer should be very brief. 0.3. What is the difference between the highest and the second highest Unemployed and educated labor force (% of population) in Tunisia?
Your response must be concise. 3. What is the difference between the highest and the lowest Unemployed and educated labor force (% of population) of Latin America(developing only)?
Offer a very short reply. 2.45. What is the difference between the highest and the lowest Unemployed and educated labor force (% of population) in Indonesia?
Offer a very short reply. 5.1. 